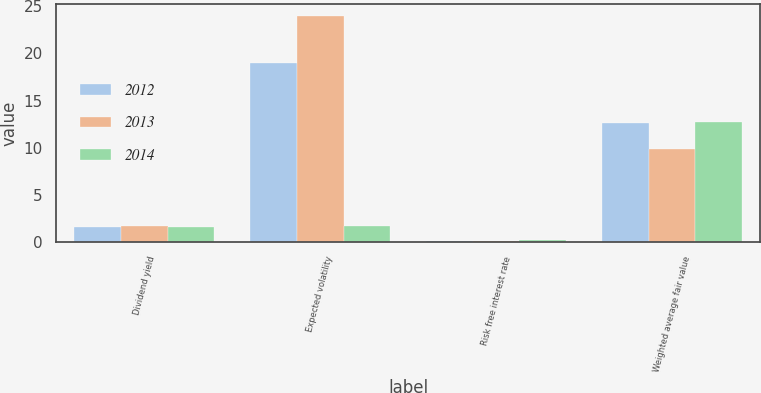Convert chart. <chart><loc_0><loc_0><loc_500><loc_500><stacked_bar_chart><ecel><fcel>Dividend yield<fcel>Expected volatility<fcel>Risk free interest rate<fcel>Weighted average fair value<nl><fcel>2012<fcel>1.6<fcel>19<fcel>0.1<fcel>12.67<nl><fcel>2013<fcel>1.7<fcel>24<fcel>0.1<fcel>9.91<nl><fcel>2014<fcel>1.6<fcel>1.7<fcel>0.2<fcel>12.71<nl></chart> 